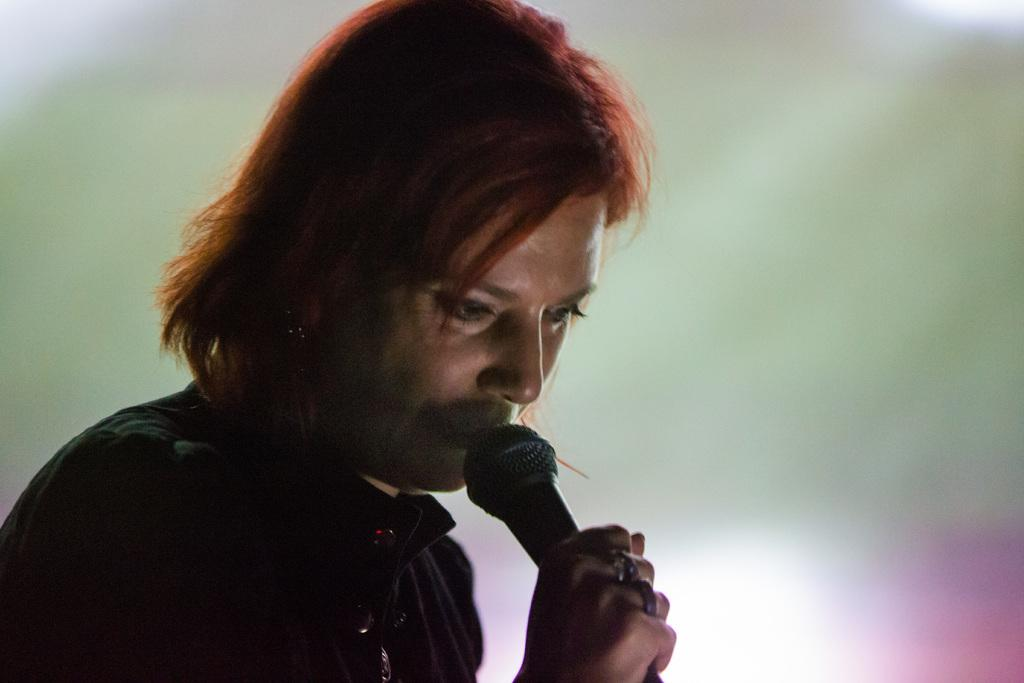Who is the main subject in the image? There is a woman in the image. What is the woman doing in the image? The woman is singing a song. What object is the woman holding in her hand? The woman is holding a microphone in her hand. Where is the woman located in the image? The woman is present over a place. What type of humor can be seen in the woman's facial expression in the image? There is no indication of humor or any specific facial expression in the image; it only shows the woman singing with a microphone. 